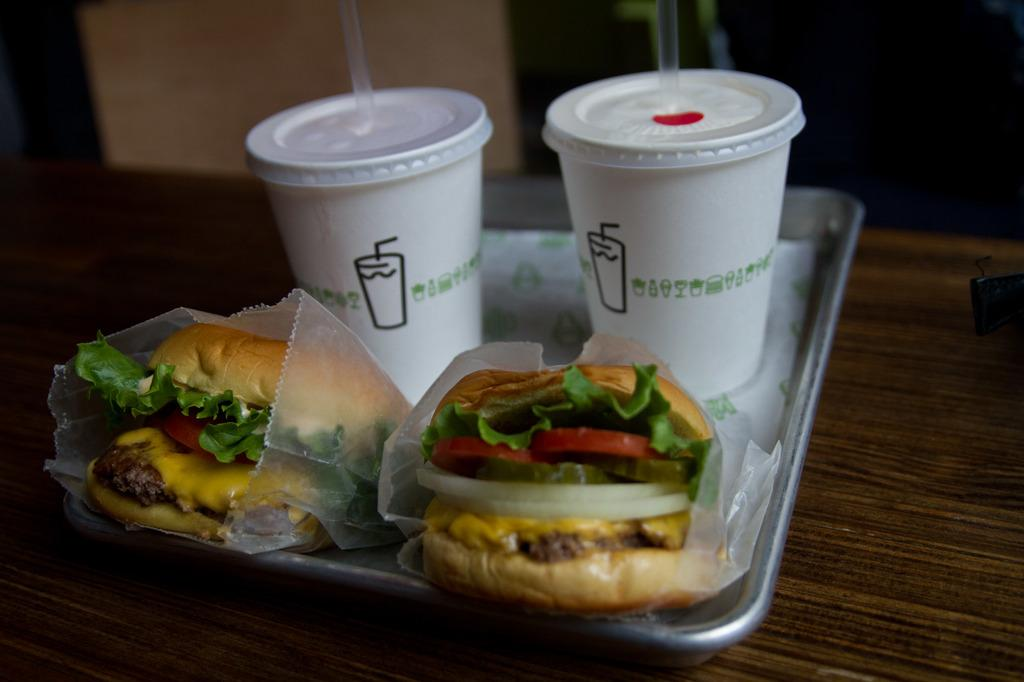What type of containers are visible in the image? There are cups with straws in the image. What type of food is on the tray in the image? There are burgers on a tray in the image. Where is the tray located in the image? The tray is on a table in the image. Can you describe the background of the image? The background of the image is blurred. What color are the eggs on the sail in the image? There are no eggs or sail present in the image. 